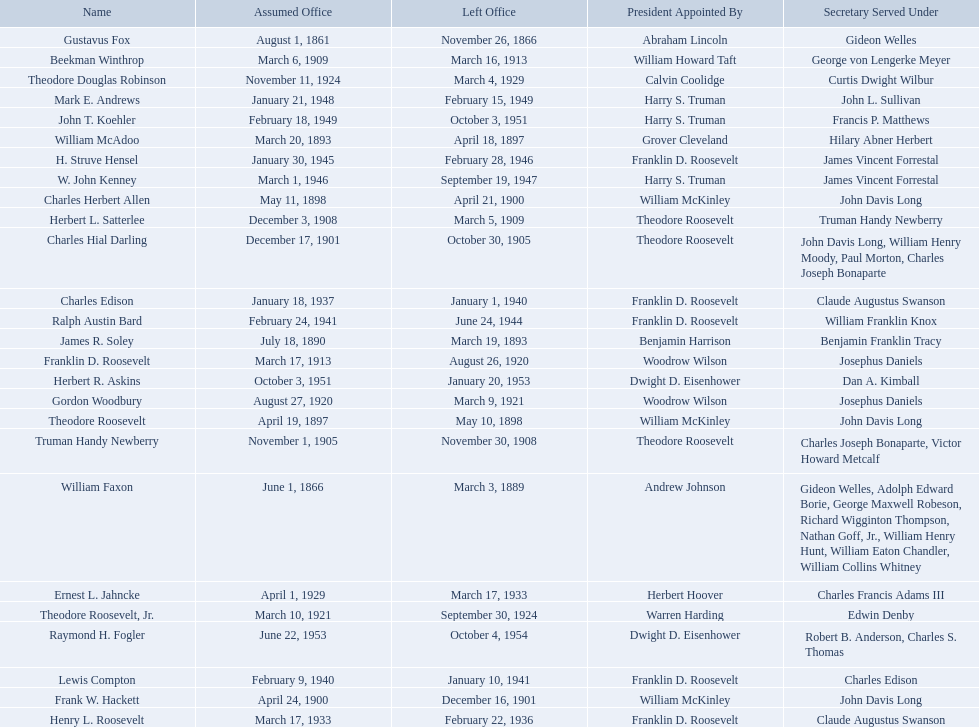Who are all of the assistant secretaries of the navy in the 20th century? Charles Herbert Allen, Frank W. Hackett, Charles Hial Darling, Truman Handy Newberry, Herbert L. Satterlee, Beekman Winthrop, Franklin D. Roosevelt, Gordon Woodbury, Theodore Roosevelt, Jr., Theodore Douglas Robinson, Ernest L. Jahncke, Henry L. Roosevelt, Charles Edison, Lewis Compton, Ralph Austin Bard, H. Struve Hensel, W. John Kenney, Mark E. Andrews, John T. Koehler, Herbert R. Askins, Raymond H. Fogler. What date was assistant secretary of the navy raymond h. fogler appointed? June 22, 1953. What date did assistant secretary of the navy raymond h. fogler leave office? October 4, 1954. 